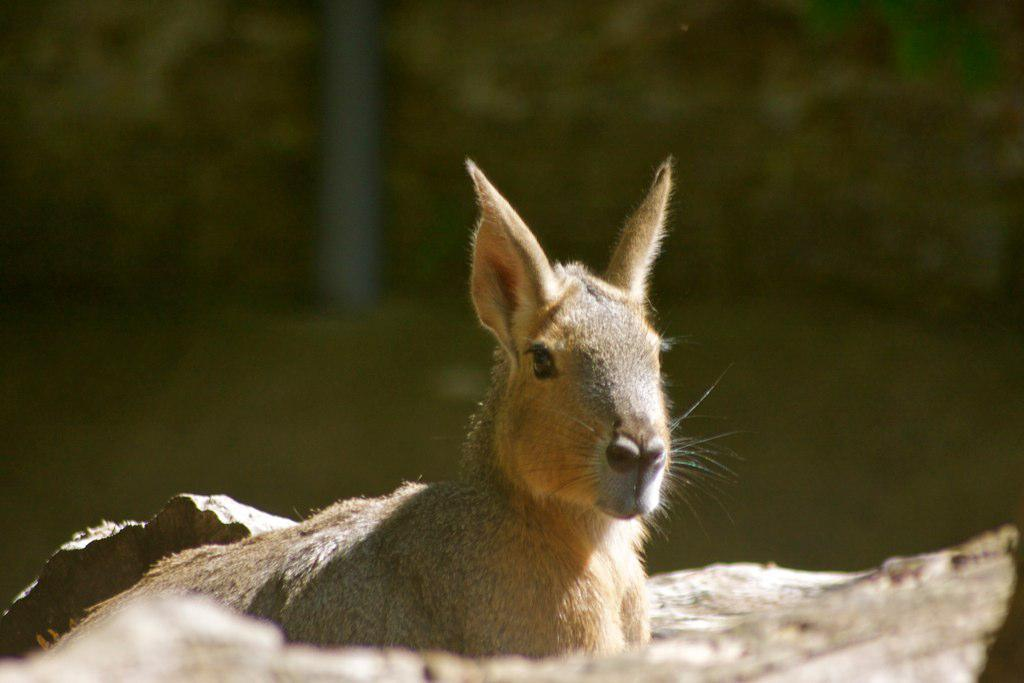What type of living creature is present in the image? There is an animal in the image. What else can be seen in the image besides the animal? There is an object in the image. Where are the animal and object located in the image? The animal and object are located towards the bottom of the image. How would you describe the background of the image? The background of the image is blurred. What type of humor can be seen in the image? There is no humor present in the image; it features an animal and an object in a blurred background. 